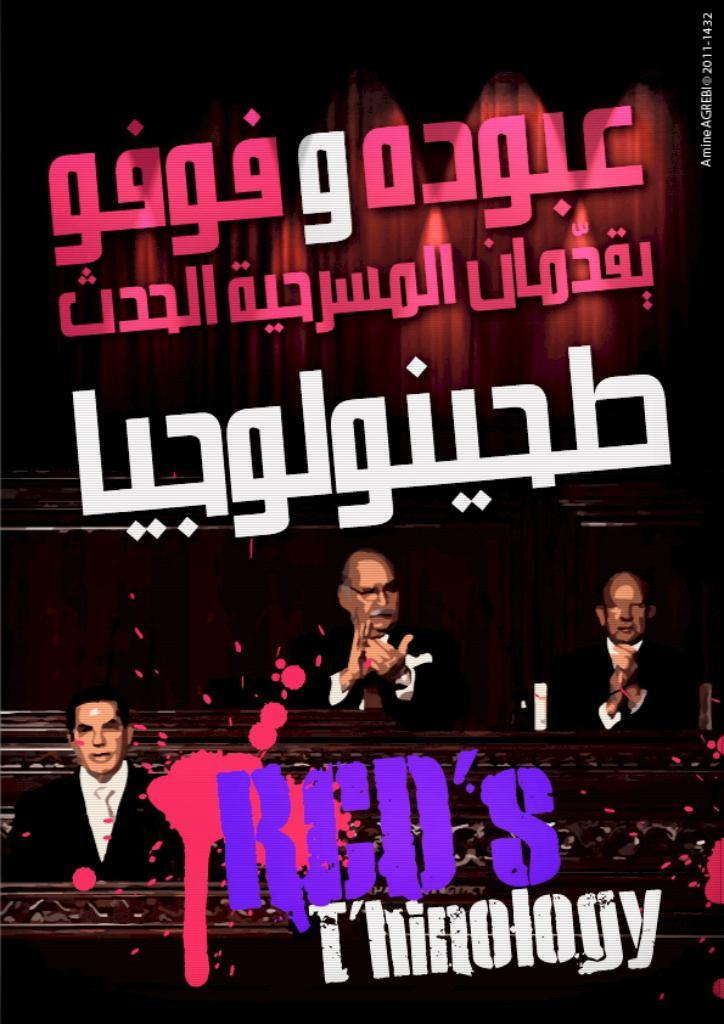What is featured in the image? There is a poster in the image. What can be seen on the poster? The poster contains images of people and text. How much powder is on the poster in the image? There is no mention of powder on the poster or in the image, so it cannot be determined. 